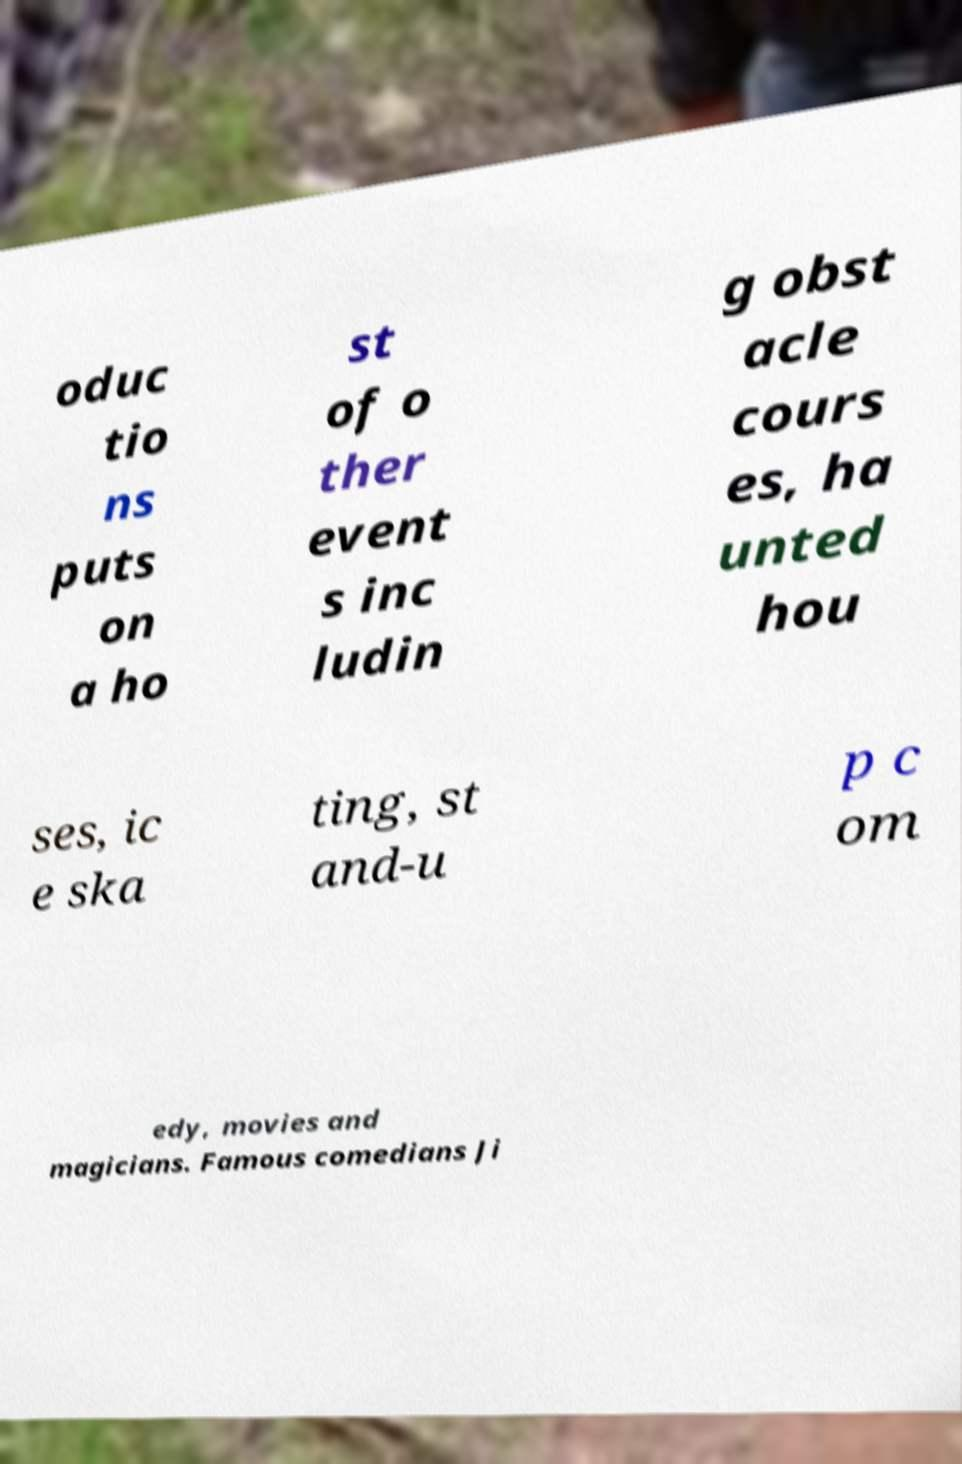What messages or text are displayed in this image? I need them in a readable, typed format. oduc tio ns puts on a ho st of o ther event s inc ludin g obst acle cours es, ha unted hou ses, ic e ska ting, st and-u p c om edy, movies and magicians. Famous comedians Ji 